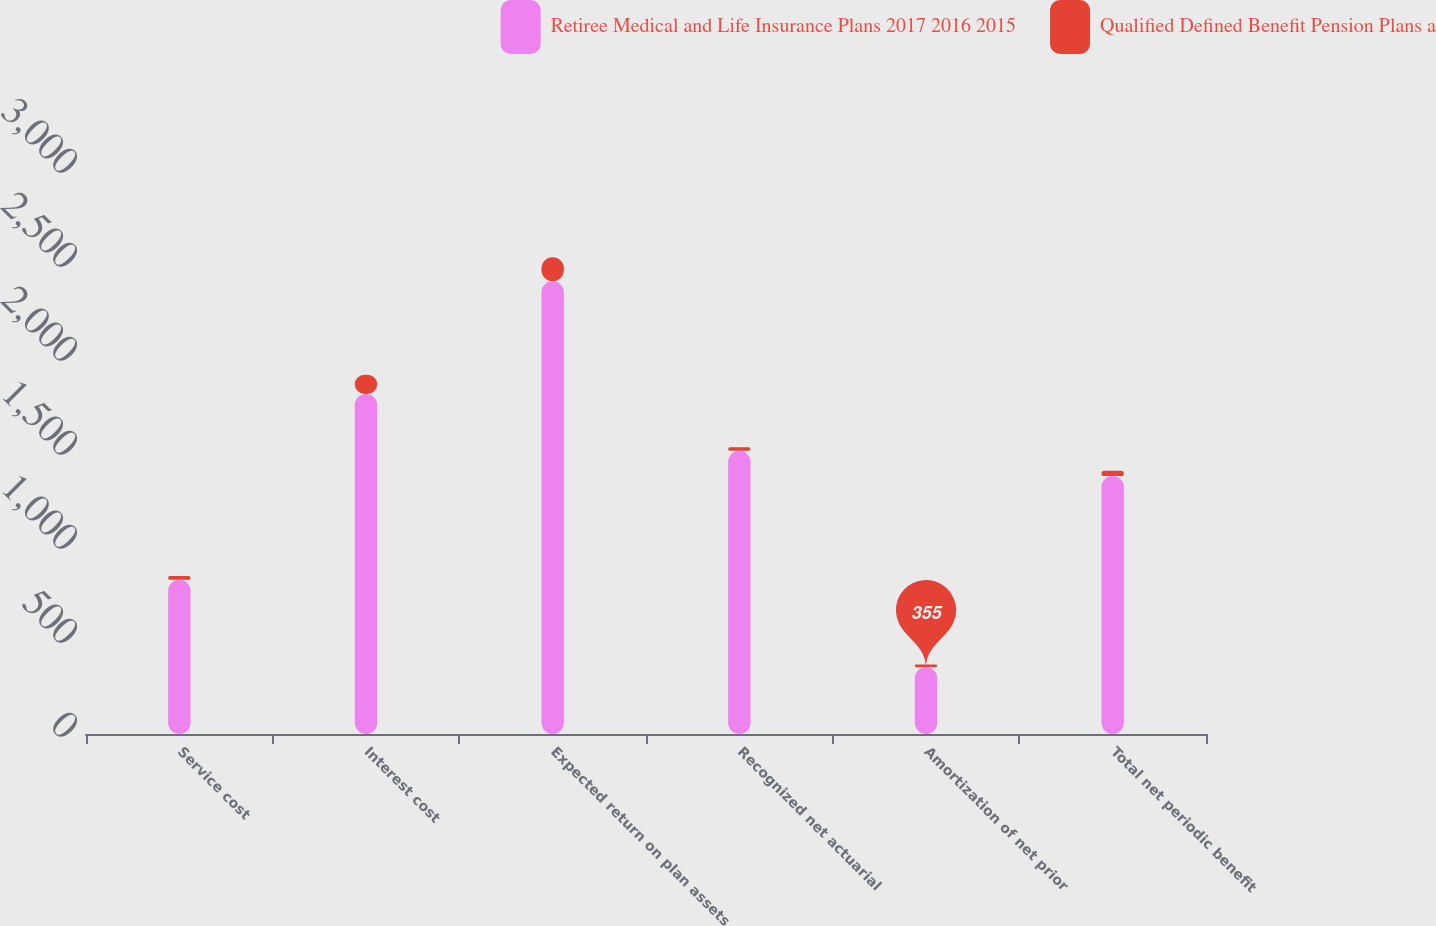Convert chart to OTSL. <chart><loc_0><loc_0><loc_500><loc_500><stacked_bar_chart><ecel><fcel>Service cost<fcel>Interest cost<fcel>Expected return on plan assets<fcel>Recognized net actuarial<fcel>Amortization of net prior<fcel>Total net periodic benefit<nl><fcel>Retiree Medical and Life Insurance Plans 2017 2016 2015<fcel>820<fcel>1809<fcel>2408<fcel>1506<fcel>355<fcel>1372<nl><fcel>Qualified Defined Benefit Pension Plans a<fcel>20<fcel>102<fcel>128<fcel>19<fcel>15<fcel>28<nl></chart> 